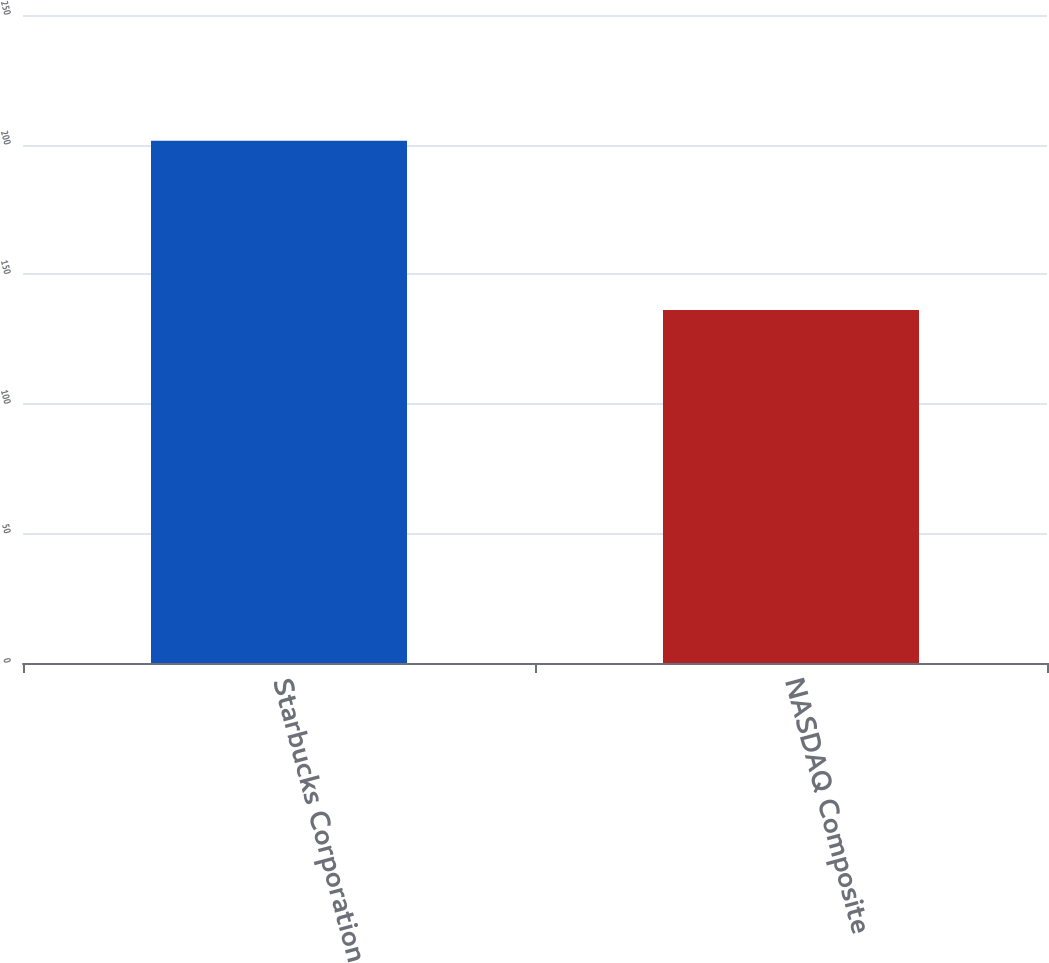Convert chart. <chart><loc_0><loc_0><loc_500><loc_500><bar_chart><fcel>Starbucks Corporation<fcel>NASDAQ Composite<nl><fcel>201.46<fcel>136.22<nl></chart> 